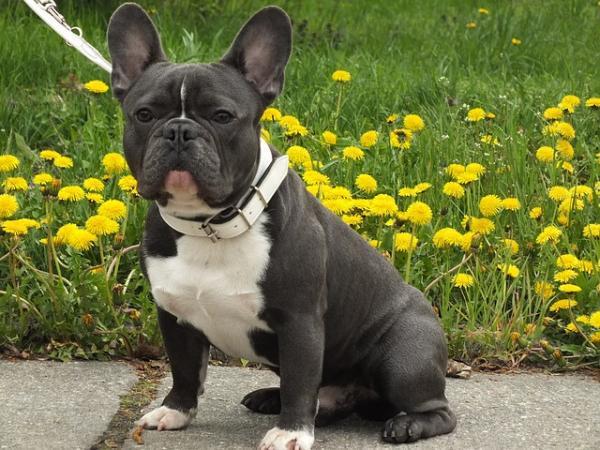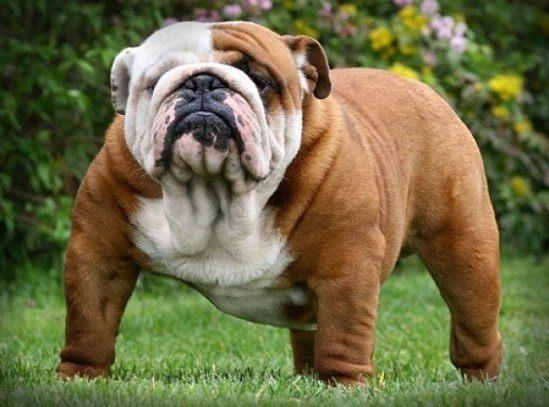The first image is the image on the left, the second image is the image on the right. Given the left and right images, does the statement "The right image contains exactly three bulldogs." hold true? Answer yes or no. No. The first image is the image on the left, the second image is the image on the right. For the images shown, is this caption "There are exactly three bulldogs in each image" true? Answer yes or no. No. 